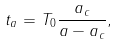<formula> <loc_0><loc_0><loc_500><loc_500>t _ { a } = T _ { 0 } \frac { a _ { c } } { a - a _ { c } } ,</formula> 